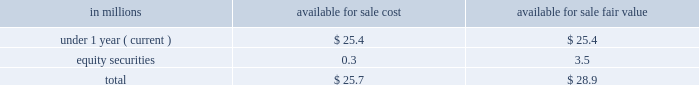Scheduled maturities of our marketable securities are as follows: .
As of may 27 , 2018 , we did not any have cash and cash equivalents pledged as collateral for derivative contracts .
As of may 27 , 2018 , $ 0.9 million of certain accounts receivable were pledged as collateral against a foreign uncommitted line of credit .
The fair value and carrying amounts of long-term debt , including the current portion , were $ 14169.7 million and $ 14268.8 million , respectively , as of may 27 , 2018 .
The fair value of long-term debt was estimated using market quotations and discounted cash flows based on our current incremental borrowing rates for similar types of instruments .
Long-term debt is a level 2 liability in the fair value hierarchy .
Risk management activities as a part of our ongoing operations , we are exposed to market risks such as changes in interest and foreign currency exchange rates and commodity and equity prices .
To manage these risks , we may enter into various derivative transactions ( e.g. , futures , options , and swaps ) pursuant to our established policies .
Commodity price risk many commodities we use in the production and distribution of our products are exposed to market price risks .
We utilize derivatives to manage price risk for our principal ingredients and energy costs , including grains ( oats , wheat , and corn ) , oils ( principally soybean ) , dairy products , natural gas , and diesel fuel .
Our primary objective when entering into these derivative contracts is to achieve certainty with regard to the future price of commodities purchased for use in our supply chain .
We manage our exposures through a combination of purchase orders , long-term contracts with suppliers , exchange-traded futures and options , and over-the-counter options and swaps .
We offset our exposures based on current and projected market conditions and generally seek to acquire the inputs at as close to our planned cost as possible .
We use derivatives to manage our exposure to changes in commodity prices .
We do not perform the assessments required to achieve hedge accounting for commodity derivative positions .
Accordingly , the changes in the values of these derivatives are recorded currently in cost of sales in our consolidated statements of earnings .
Although we do not meet the criteria for cash flow hedge accounting , we believe that these instruments are effective in achieving our objective of providing certainty in the future price of commodities purchased for use in our supply chain .
Accordingly , for purposes of measuring segment operating performance these gains and losses are reported in unallocated corporate items outside of segment operating results until such time that the exposure we are managing affects earnings .
At that time we reclassify the gain or loss from unallocated corporate items to segment operating profit , allowing our operating segments to realize the economic effects of the derivative without experiencing any resulting mark-to-market volatility , which remains in unallocated corporate items. .
What would be the gain/loss if all marketable securities are sold at fair value? 
Computations: (28.9 - 25.7)
Answer: 3.2. 